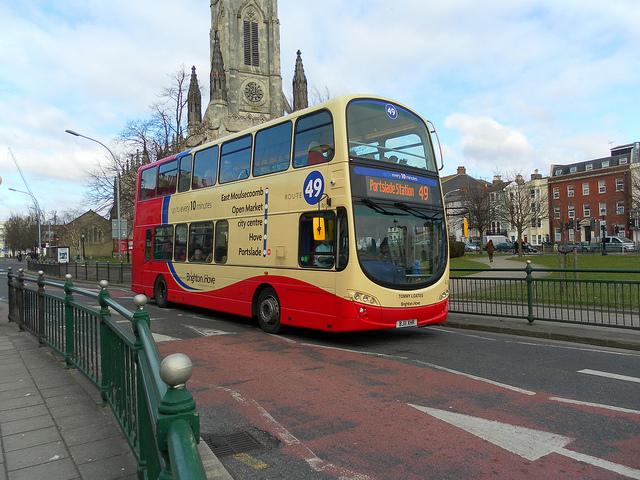What is the number inside of the blue circle?
Short answer required. 49. Is that bus going to leave soon?
Short answer required. Yes. What is the structure behind the bus?
Answer briefly. Church. 